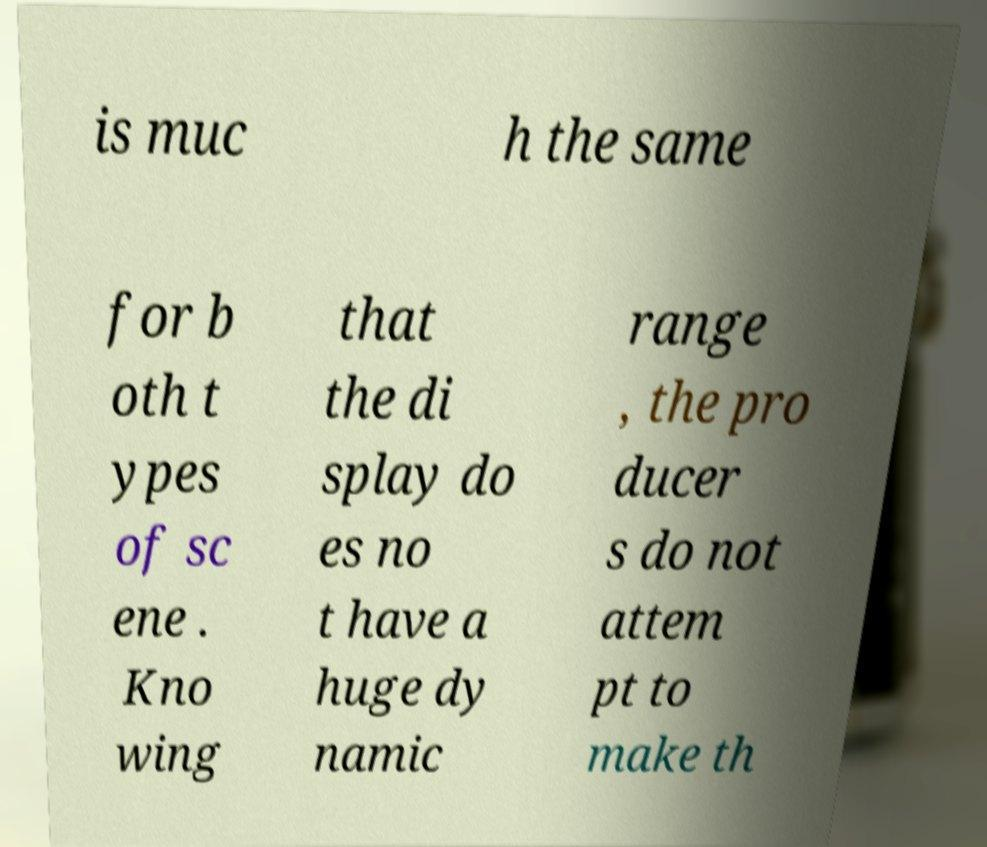Please read and relay the text visible in this image. What does it say? is muc h the same for b oth t ypes of sc ene . Kno wing that the di splay do es no t have a huge dy namic range , the pro ducer s do not attem pt to make th 